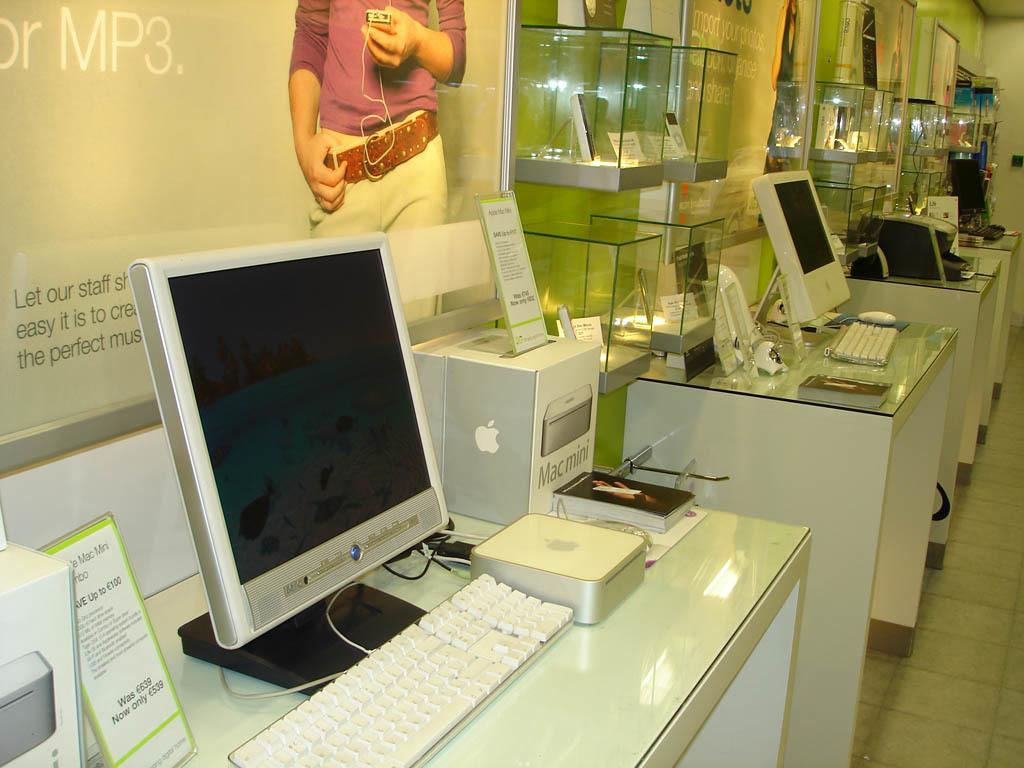<image>
Provide a brief description of the given image. A computer store prominently displays their products including a Mac mini. 